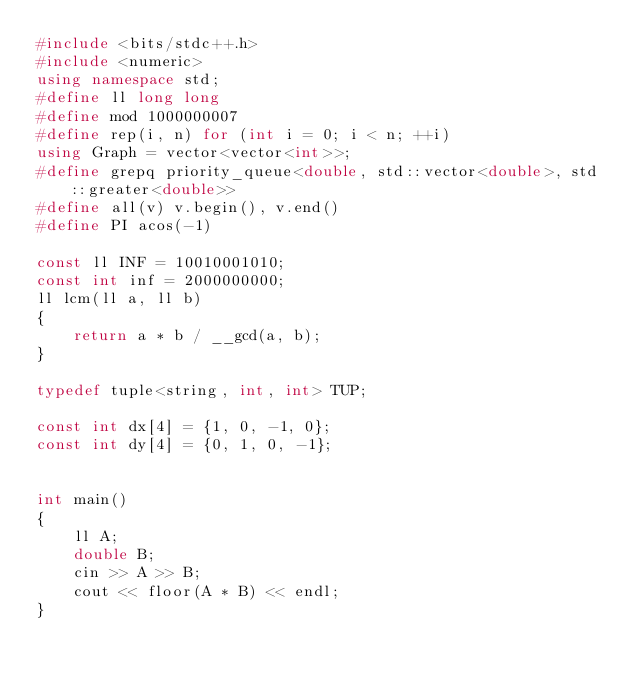<code> <loc_0><loc_0><loc_500><loc_500><_C++_>#include <bits/stdc++.h>
#include <numeric>
using namespace std;
#define ll long long
#define mod 1000000007
#define rep(i, n) for (int i = 0; i < n; ++i)
using Graph = vector<vector<int>>;
#define grepq priority_queue<double, std::vector<double>, std::greater<double>>
#define all(v) v.begin(), v.end()
#define PI acos(-1)

const ll INF = 10010001010;
const int inf = 2000000000;
ll lcm(ll a, ll b)
{
    return a * b / __gcd(a, b);
}

typedef tuple<string, int, int> TUP;

const int dx[4] = {1, 0, -1, 0};
const int dy[4] = {0, 1, 0, -1};


int main()
{
    ll A;
    double B;
    cin >> A >> B;
    cout << floor(A * B) << endl;
}</code> 